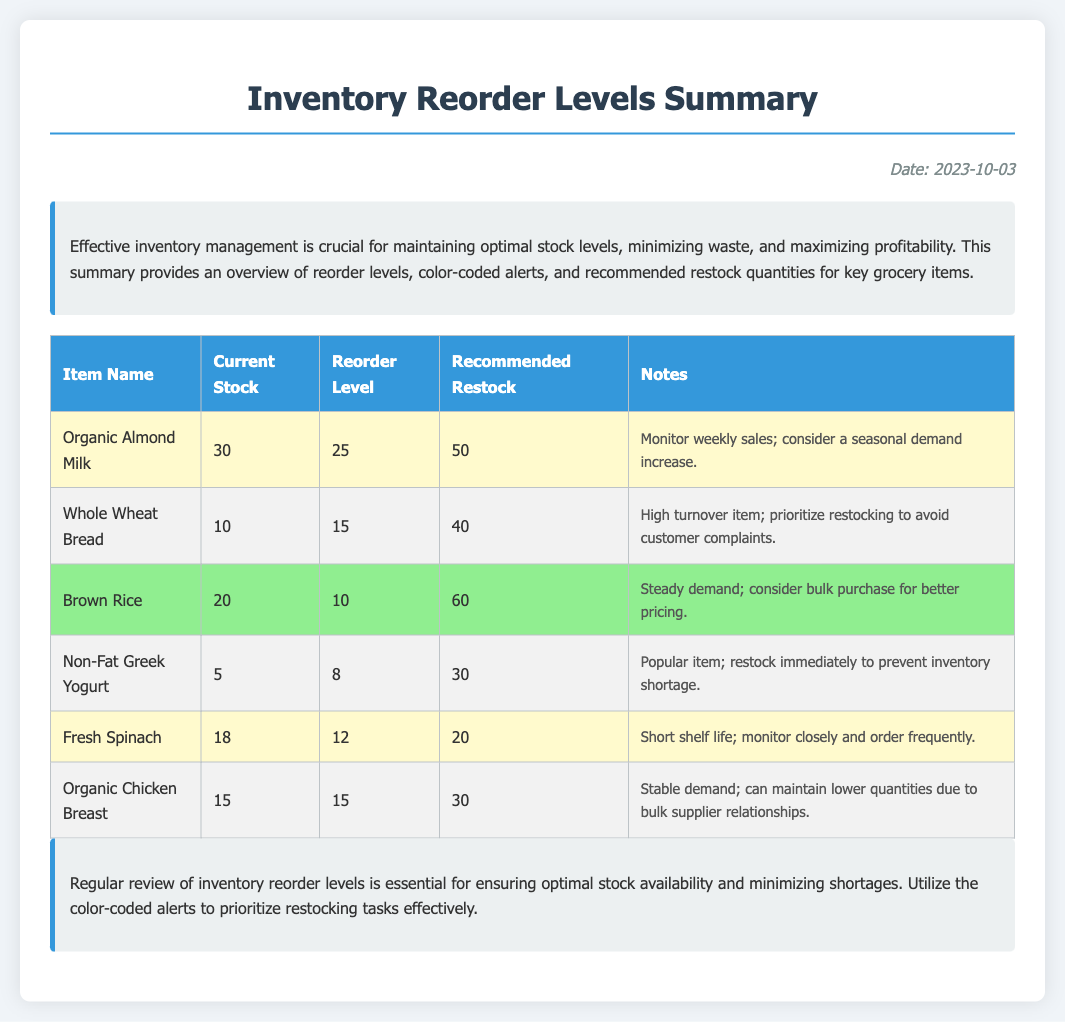What is the date of the summary? The date of the summary is mentioned in the document as the date printed on the right side.
Answer: 2023-10-03 How many items are currently in stock for Whole Wheat Bread? The current stock for Whole Wheat Bread can be found in the "Current Stock" column of the table.
Answer: 10 What is the reorder level for Organic Almond Milk? The reorder level for Organic Almond Milk is specified in the "Reorder Level" column of the table.
Answer: 25 Which item has the highest recommended restock quantity? This can be determined by comparing the values in the "Recommended Restock" column of the table.
Answer: 60 What is the color code indicating an immediate restock need? The document includes color-coded alerts that indicate different urgency levels; based on the color codes, red indicates the need for immediate restock.
Answer: Red Which item has a note suggesting monitoring closely? This information can be found in the "Notes" column for items indicating special considerations.
Answer: Fresh Spinach What is the current stock level for Non-Fat Greek Yogurt? The current stock level for Non-Fat Greek Yogurt is listed in the "Current Stock" column under its entry.
Answer: 5 Which item is classified under the alert yellow category? Look for items that have the yellow alert class assigned within the table.
Answer: Organic Almond Milk How much restock is recommended for Brown Rice? The recommended restock quantity for Brown Rice can be found in the corresponding column for that item.
Answer: 60 